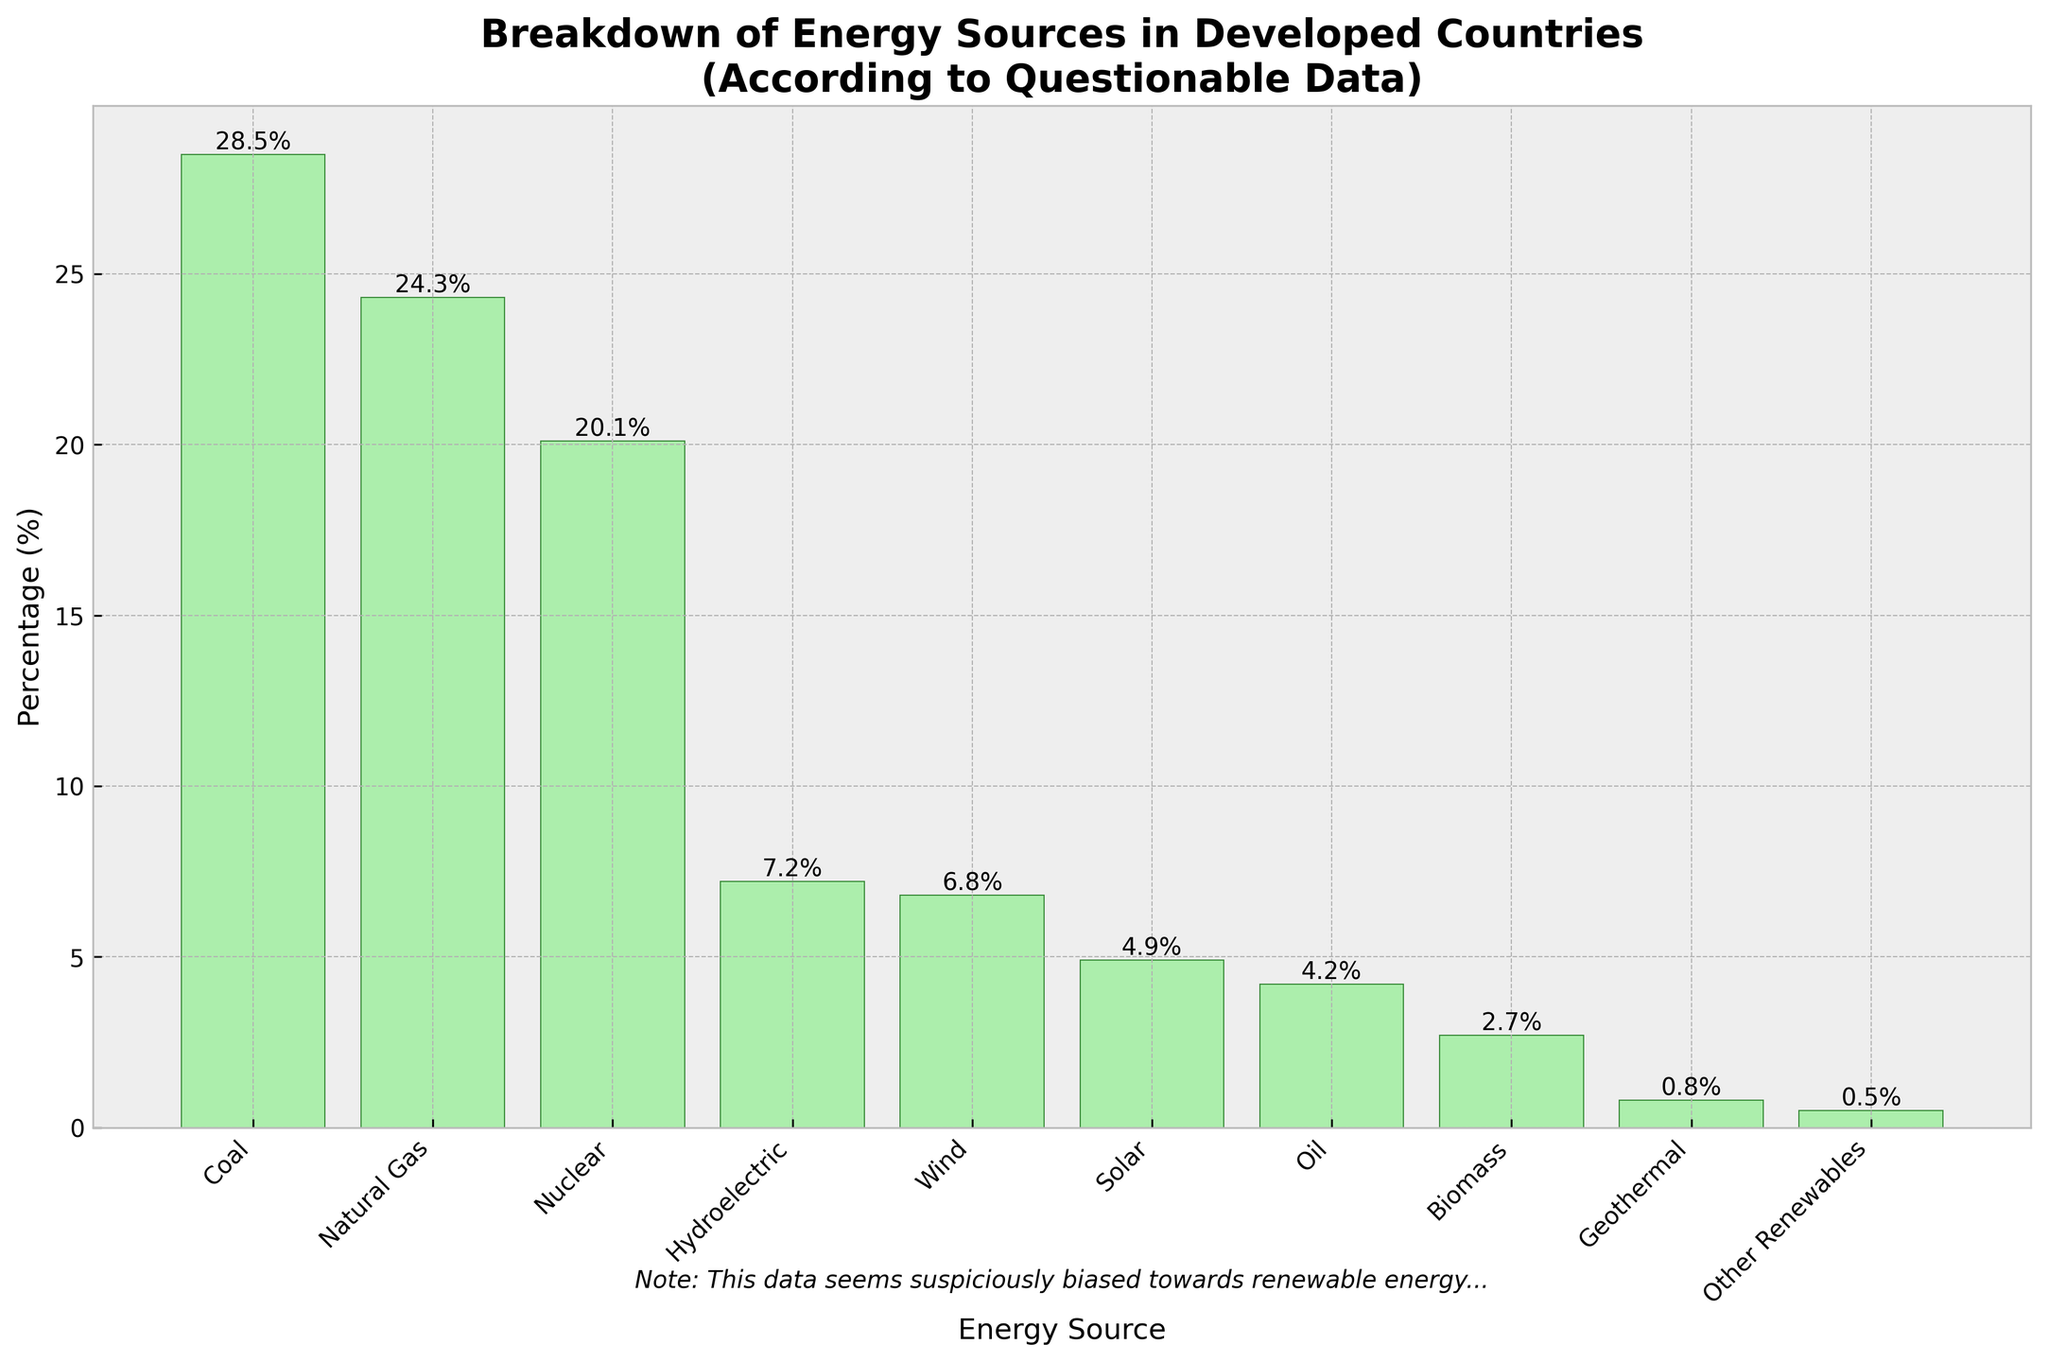what energy source has the highest percentage? The chart shows different energy sources with their corresponding percentages. By visually inspecting the heights of the bars, the bar representing 'Coal' is the tallest, indicating the highest percentage.
Answer: Coal which energy source has the lowest percentage? To determine the lowest percentage, look for the shortest bar. The bar representing 'Other Renewables' is the shortest, signifying the lowest percentage.
Answer: Other Renewables what are the combined percentages of wind, solar, and biomass energy sources? The percentages for Wind, Solar, and Biomass are 6.8%, 4.9%, and 2.7% respectively. Adding these together gives 6.8 + 4.9 + 2.7 = 14.4%.
Answer: 14.4% which energy source accounts for more: hydroelectric or solar? Compare the heights of the bars for Hydroelectric and Solar. The Hydroelectric bar (7.2%) is higher than the Solar bar (4.9%).
Answer: Hydroelectric what is the difference in percentage between natural gas and nuclear energy sources? Natural Gas accounts for 24.3% and Nuclear for 20.1%. Subtracting these gives 24.3 - 20.1 = 4.2%.
Answer: 4.2% which energy sources have percentages greater than 5%? From the chart, the bars for Coal (28.5%), Natural Gas (24.3%), Nuclear (20.1%), Hydroelectric (7.2%), and Wind (6.8%) are all greater than 5%.
Answer: Coal, Natural Gas, Nuclear, Hydroelectric, Wind how much less is oil's percentage compared to natural gas? Oil's percentage is 4.2%, and Natural Gas's percentage is 24.3%. The difference is 24.3 - 4.2 = 20.1%.
Answer: 20.1% what is the average percentage of all renewable energy sources in the data? Renewable energy sources in the data are Hydroelectric (7.2%), Wind (6.8%), Solar (4.9%), Biomass (2.7%), Geothermal (0.8%), and Other Renewables (0.5%). Their total percentage is 7.2 + 6.8 + 4.9 + 2.7 + 0.8 + 0.5 = 22.9%. Dividing by the number of sources (6) gives 22.9 / 6 ≈ 3.82%.
Answer: 3.82% which is taller: the bar for biomass or the bar for geothermal? Visually compare the heights of the bars for Biomass and Geothermal. The Biomass bar (2.7%) is taller than the Geothermal bar (0.8%).
Answer: Biomass 